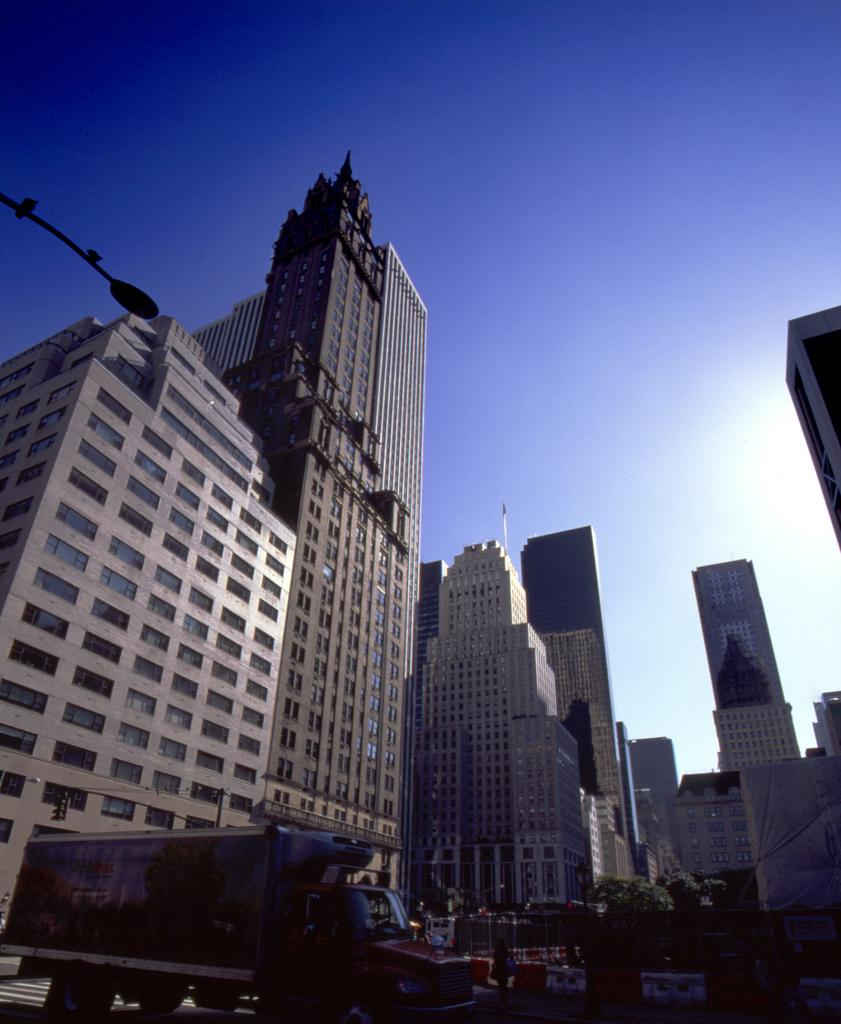What type of structures are visible in the image? There are buildings with windows in the image. What else can be seen in the image besides buildings? There are vehicles and plants visible in the image. What is visible in the background of the image? The sky is visible in the image. What type of fear can be seen on the face of the building in the image? There is no face or fear present in the image, as buildings do not have faces or emotions. 